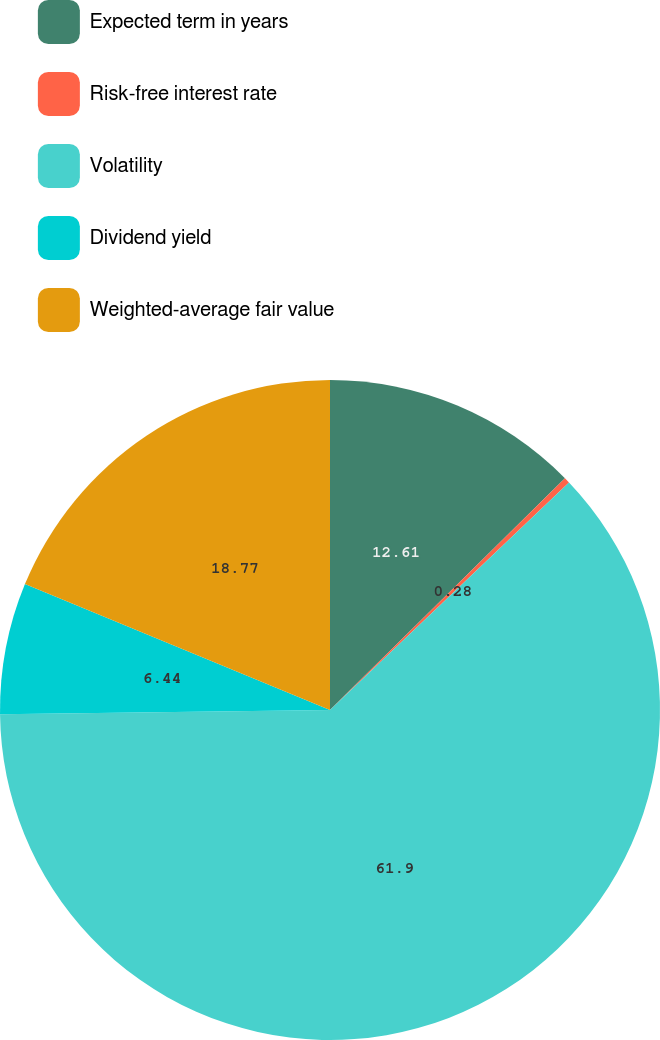<chart> <loc_0><loc_0><loc_500><loc_500><pie_chart><fcel>Expected term in years<fcel>Risk-free interest rate<fcel>Volatility<fcel>Dividend yield<fcel>Weighted-average fair value<nl><fcel>12.61%<fcel>0.28%<fcel>61.9%<fcel>6.44%<fcel>18.77%<nl></chart> 